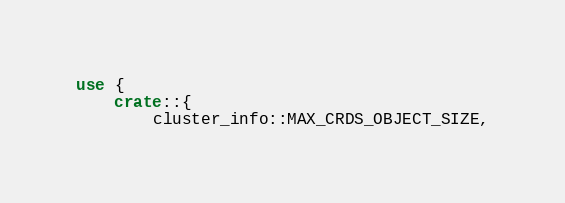<code> <loc_0><loc_0><loc_500><loc_500><_Rust_>use {
    crate::{
        cluster_info::MAX_CRDS_OBJECT_SIZE,</code> 